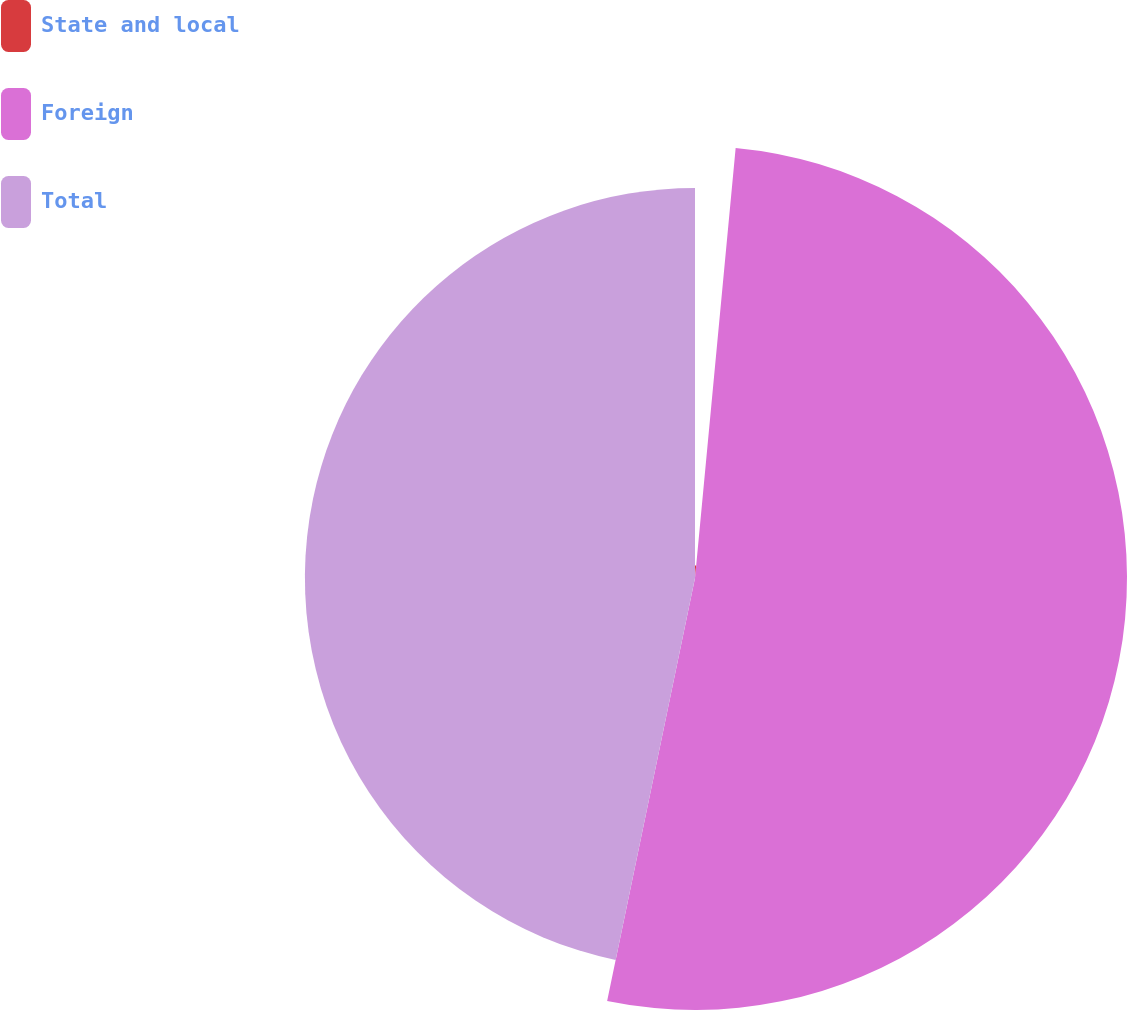Convert chart to OTSL. <chart><loc_0><loc_0><loc_500><loc_500><pie_chart><fcel>State and local<fcel>Foreign<fcel>Total<nl><fcel>1.5%<fcel>51.76%<fcel>46.74%<nl></chart> 